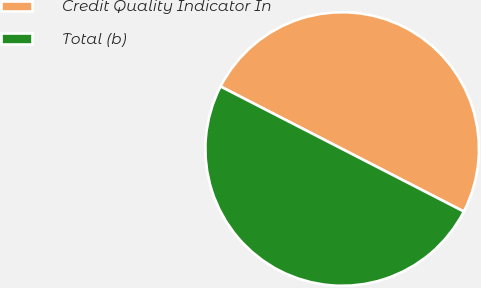<chart> <loc_0><loc_0><loc_500><loc_500><pie_chart><fcel>Credit Quality Indicator In<fcel>Total (b)<nl><fcel>50.0%<fcel>50.0%<nl></chart> 